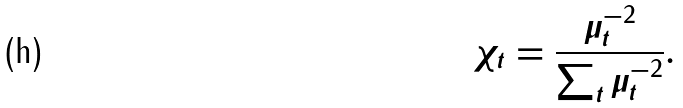Convert formula to latex. <formula><loc_0><loc_0><loc_500><loc_500>\chi _ { t } = \frac { \mu _ { t } ^ { - 2 } } { \sum _ { t } \mu _ { t } ^ { - 2 } } .</formula> 